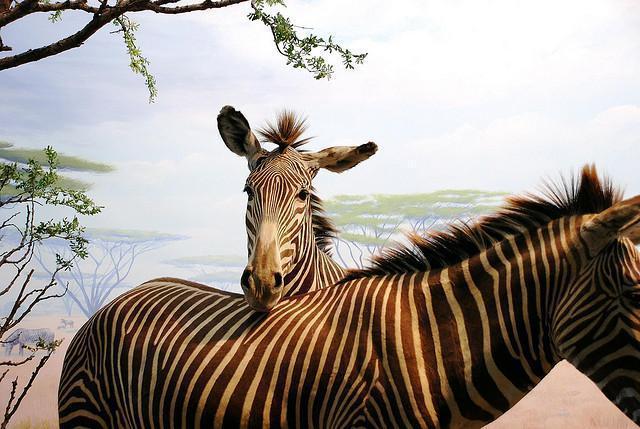How many zebras are in the scene?
Give a very brief answer. 2. How many zebras are in the photo?
Give a very brief answer. 2. How many men are shown?
Give a very brief answer. 0. 